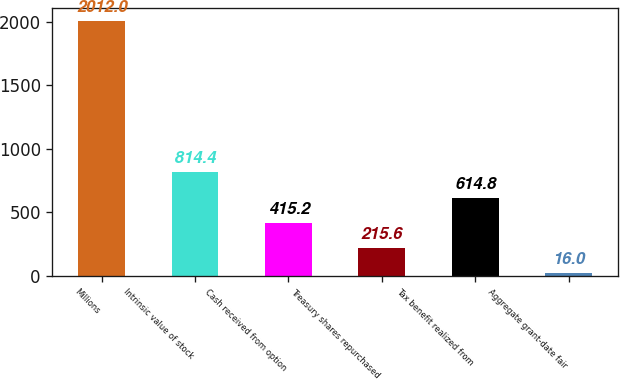<chart> <loc_0><loc_0><loc_500><loc_500><bar_chart><fcel>Millions<fcel>Intrinsic value of stock<fcel>Cash received from option<fcel>Treasury shares repurchased<fcel>Tax benefit realized from<fcel>Aggregate grant-date fair<nl><fcel>2012<fcel>814.4<fcel>415.2<fcel>215.6<fcel>614.8<fcel>16<nl></chart> 